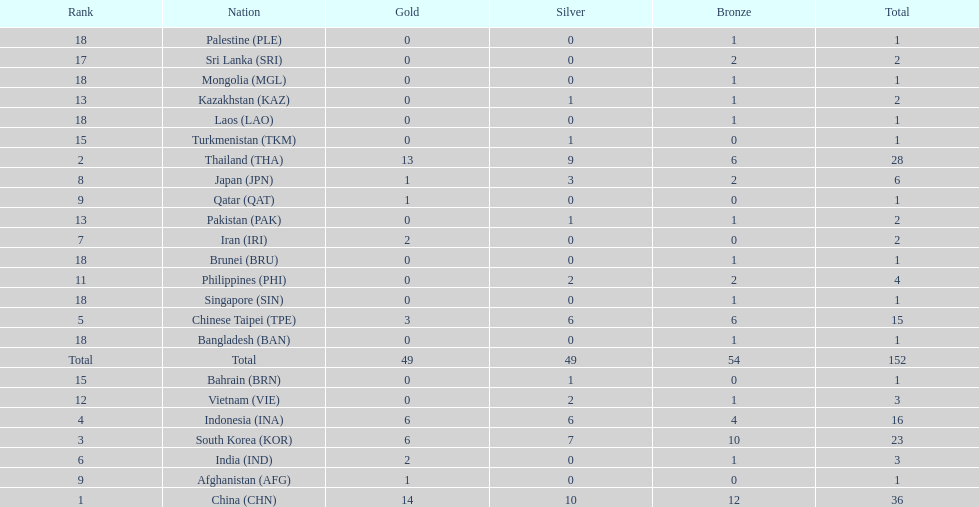What is the total number of nations that participated in the beach games of 2012? 23. 